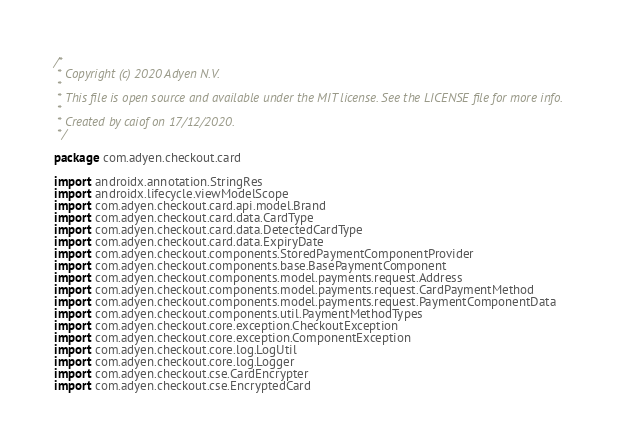<code> <loc_0><loc_0><loc_500><loc_500><_Kotlin_>/*
 * Copyright (c) 2020 Adyen N.V.
 *
 * This file is open source and available under the MIT license. See the LICENSE file for more info.
 *
 * Created by caiof on 17/12/2020.
 */

package com.adyen.checkout.card

import androidx.annotation.StringRes
import androidx.lifecycle.viewModelScope
import com.adyen.checkout.card.api.model.Brand
import com.adyen.checkout.card.data.CardType
import com.adyen.checkout.card.data.DetectedCardType
import com.adyen.checkout.card.data.ExpiryDate
import com.adyen.checkout.components.StoredPaymentComponentProvider
import com.adyen.checkout.components.base.BasePaymentComponent
import com.adyen.checkout.components.model.payments.request.Address
import com.adyen.checkout.components.model.payments.request.CardPaymentMethod
import com.adyen.checkout.components.model.payments.request.PaymentComponentData
import com.adyen.checkout.components.util.PaymentMethodTypes
import com.adyen.checkout.core.exception.CheckoutException
import com.adyen.checkout.core.exception.ComponentException
import com.adyen.checkout.core.log.LogUtil
import com.adyen.checkout.core.log.Logger
import com.adyen.checkout.cse.CardEncrypter
import com.adyen.checkout.cse.EncryptedCard</code> 